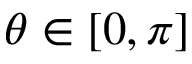Convert formula to latex. <formula><loc_0><loc_0><loc_500><loc_500>\theta \in [ 0 , \pi ]</formula> 